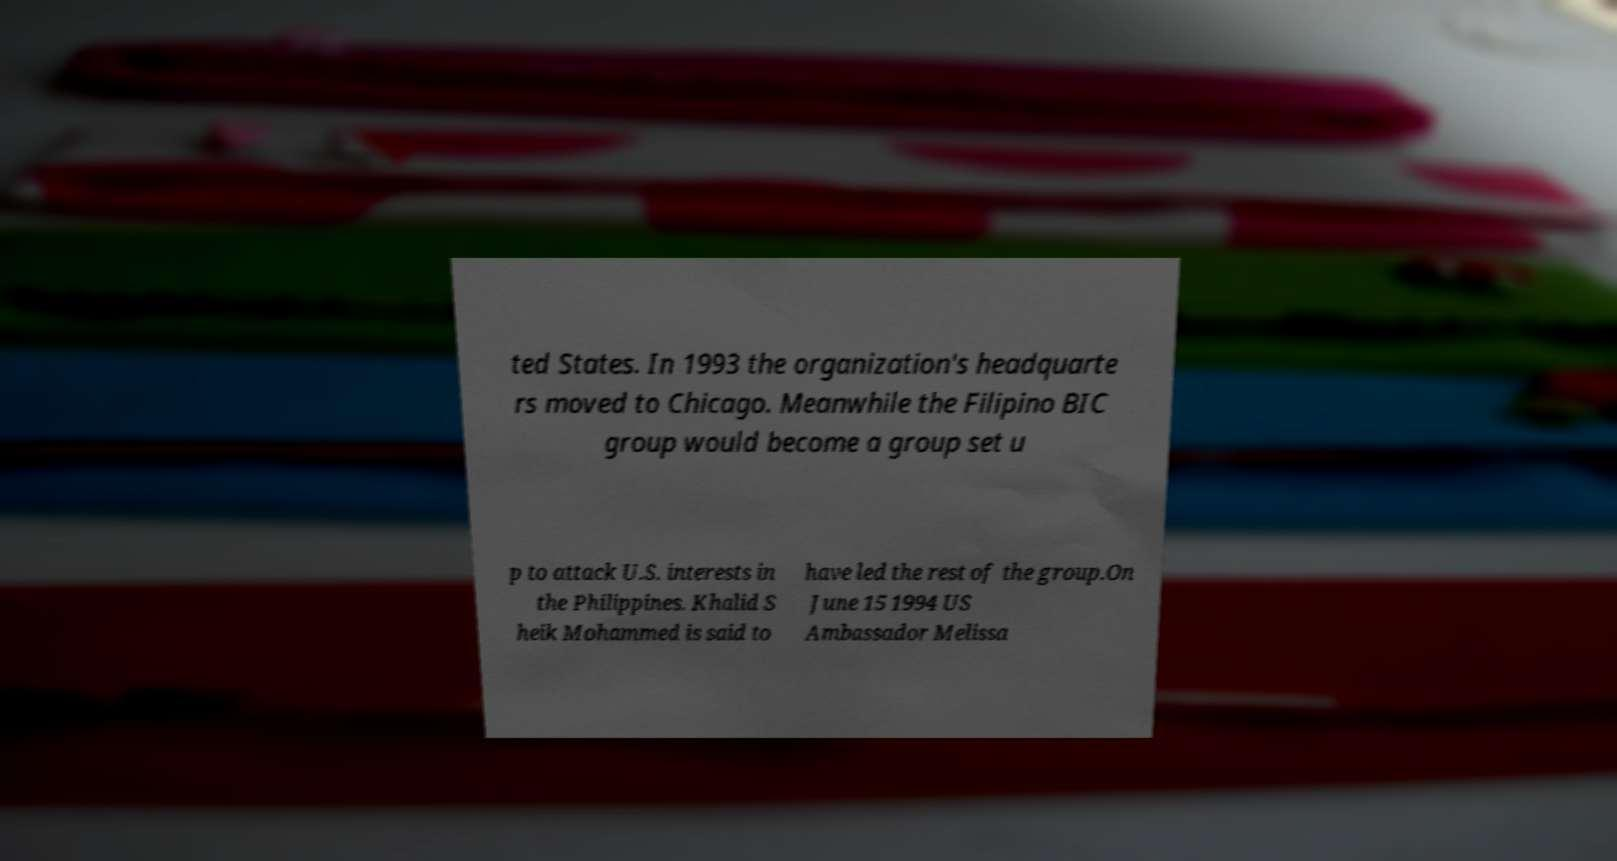Can you read and provide the text displayed in the image?This photo seems to have some interesting text. Can you extract and type it out for me? ted States. In 1993 the organization's headquarte rs moved to Chicago. Meanwhile the Filipino BIC group would become a group set u p to attack U.S. interests in the Philippines. Khalid S heik Mohammed is said to have led the rest of the group.On June 15 1994 US Ambassador Melissa 